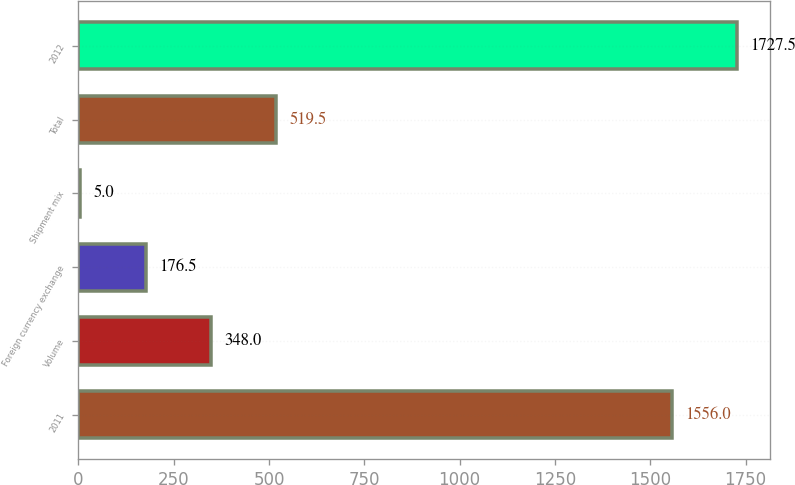<chart> <loc_0><loc_0><loc_500><loc_500><bar_chart><fcel>2011<fcel>Volume<fcel>Foreign currency exchange<fcel>Shipment mix<fcel>Total<fcel>2012<nl><fcel>1556<fcel>348<fcel>176.5<fcel>5<fcel>519.5<fcel>1727.5<nl></chart> 